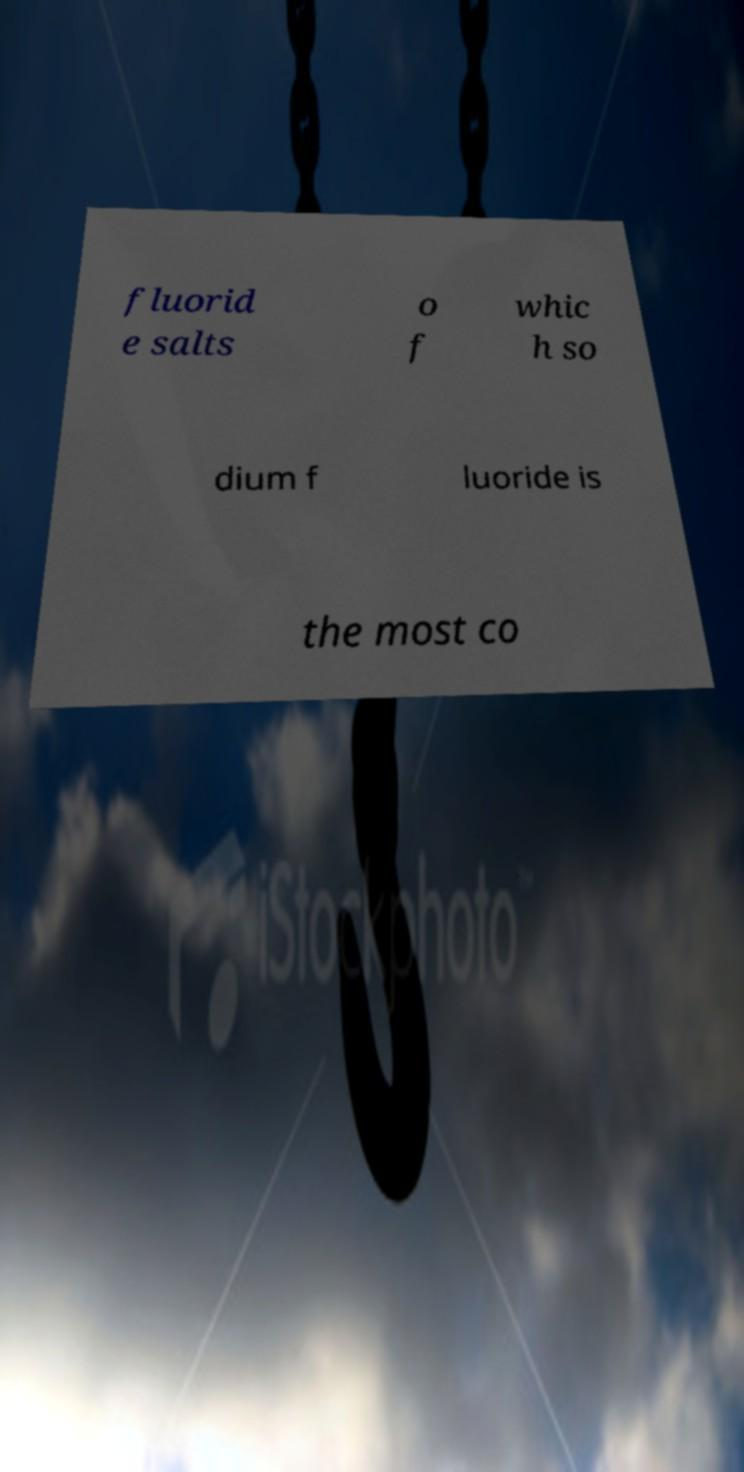Can you read and provide the text displayed in the image?This photo seems to have some interesting text. Can you extract and type it out for me? fluorid e salts o f whic h so dium f luoride is the most co 